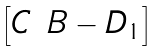<formula> <loc_0><loc_0><loc_500><loc_500>\begin{bmatrix} C & B - D _ { 1 } \end{bmatrix}</formula> 